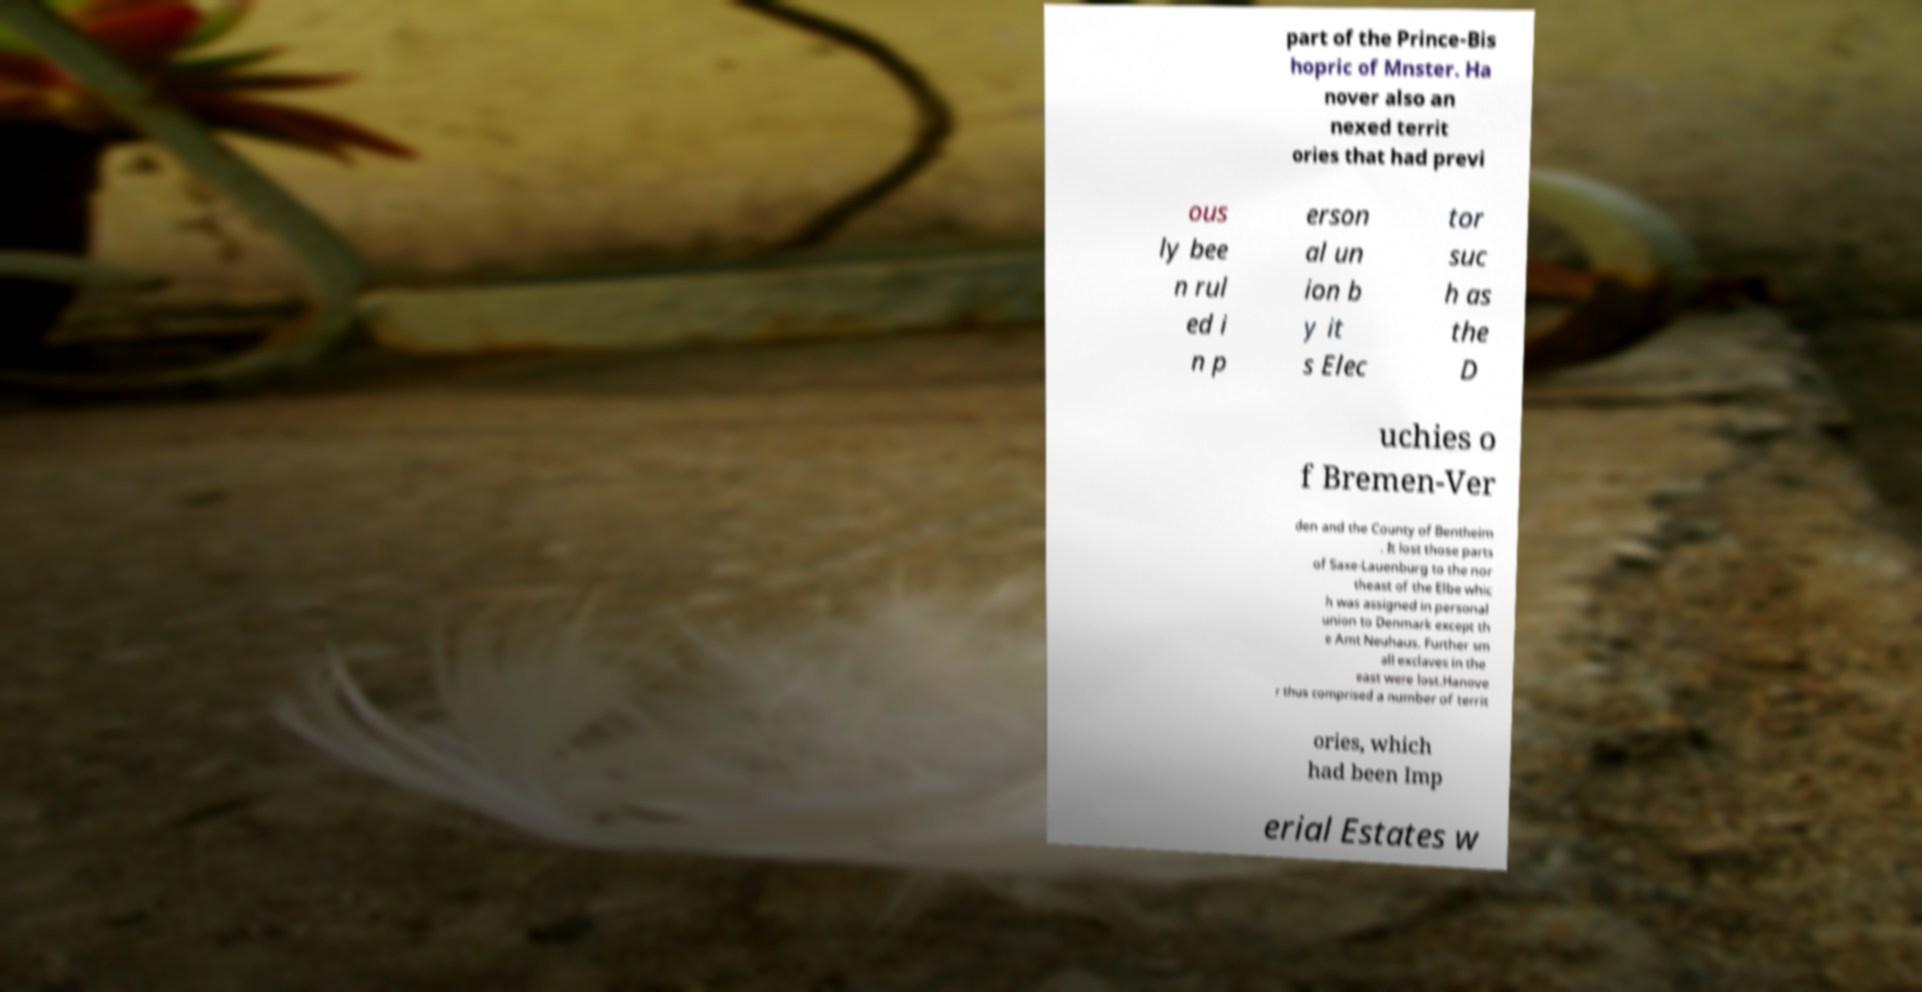For documentation purposes, I need the text within this image transcribed. Could you provide that? part of the Prince-Bis hopric of Mnster. Ha nover also an nexed territ ories that had previ ous ly bee n rul ed i n p erson al un ion b y it s Elec tor suc h as the D uchies o f Bremen-Ver den and the County of Bentheim . It lost those parts of Saxe-Lauenburg to the nor theast of the Elbe whic h was assigned in personal union to Denmark except th e Amt Neuhaus. Further sm all exclaves in the east were lost.Hanove r thus comprised a number of territ ories, which had been Imp erial Estates w 